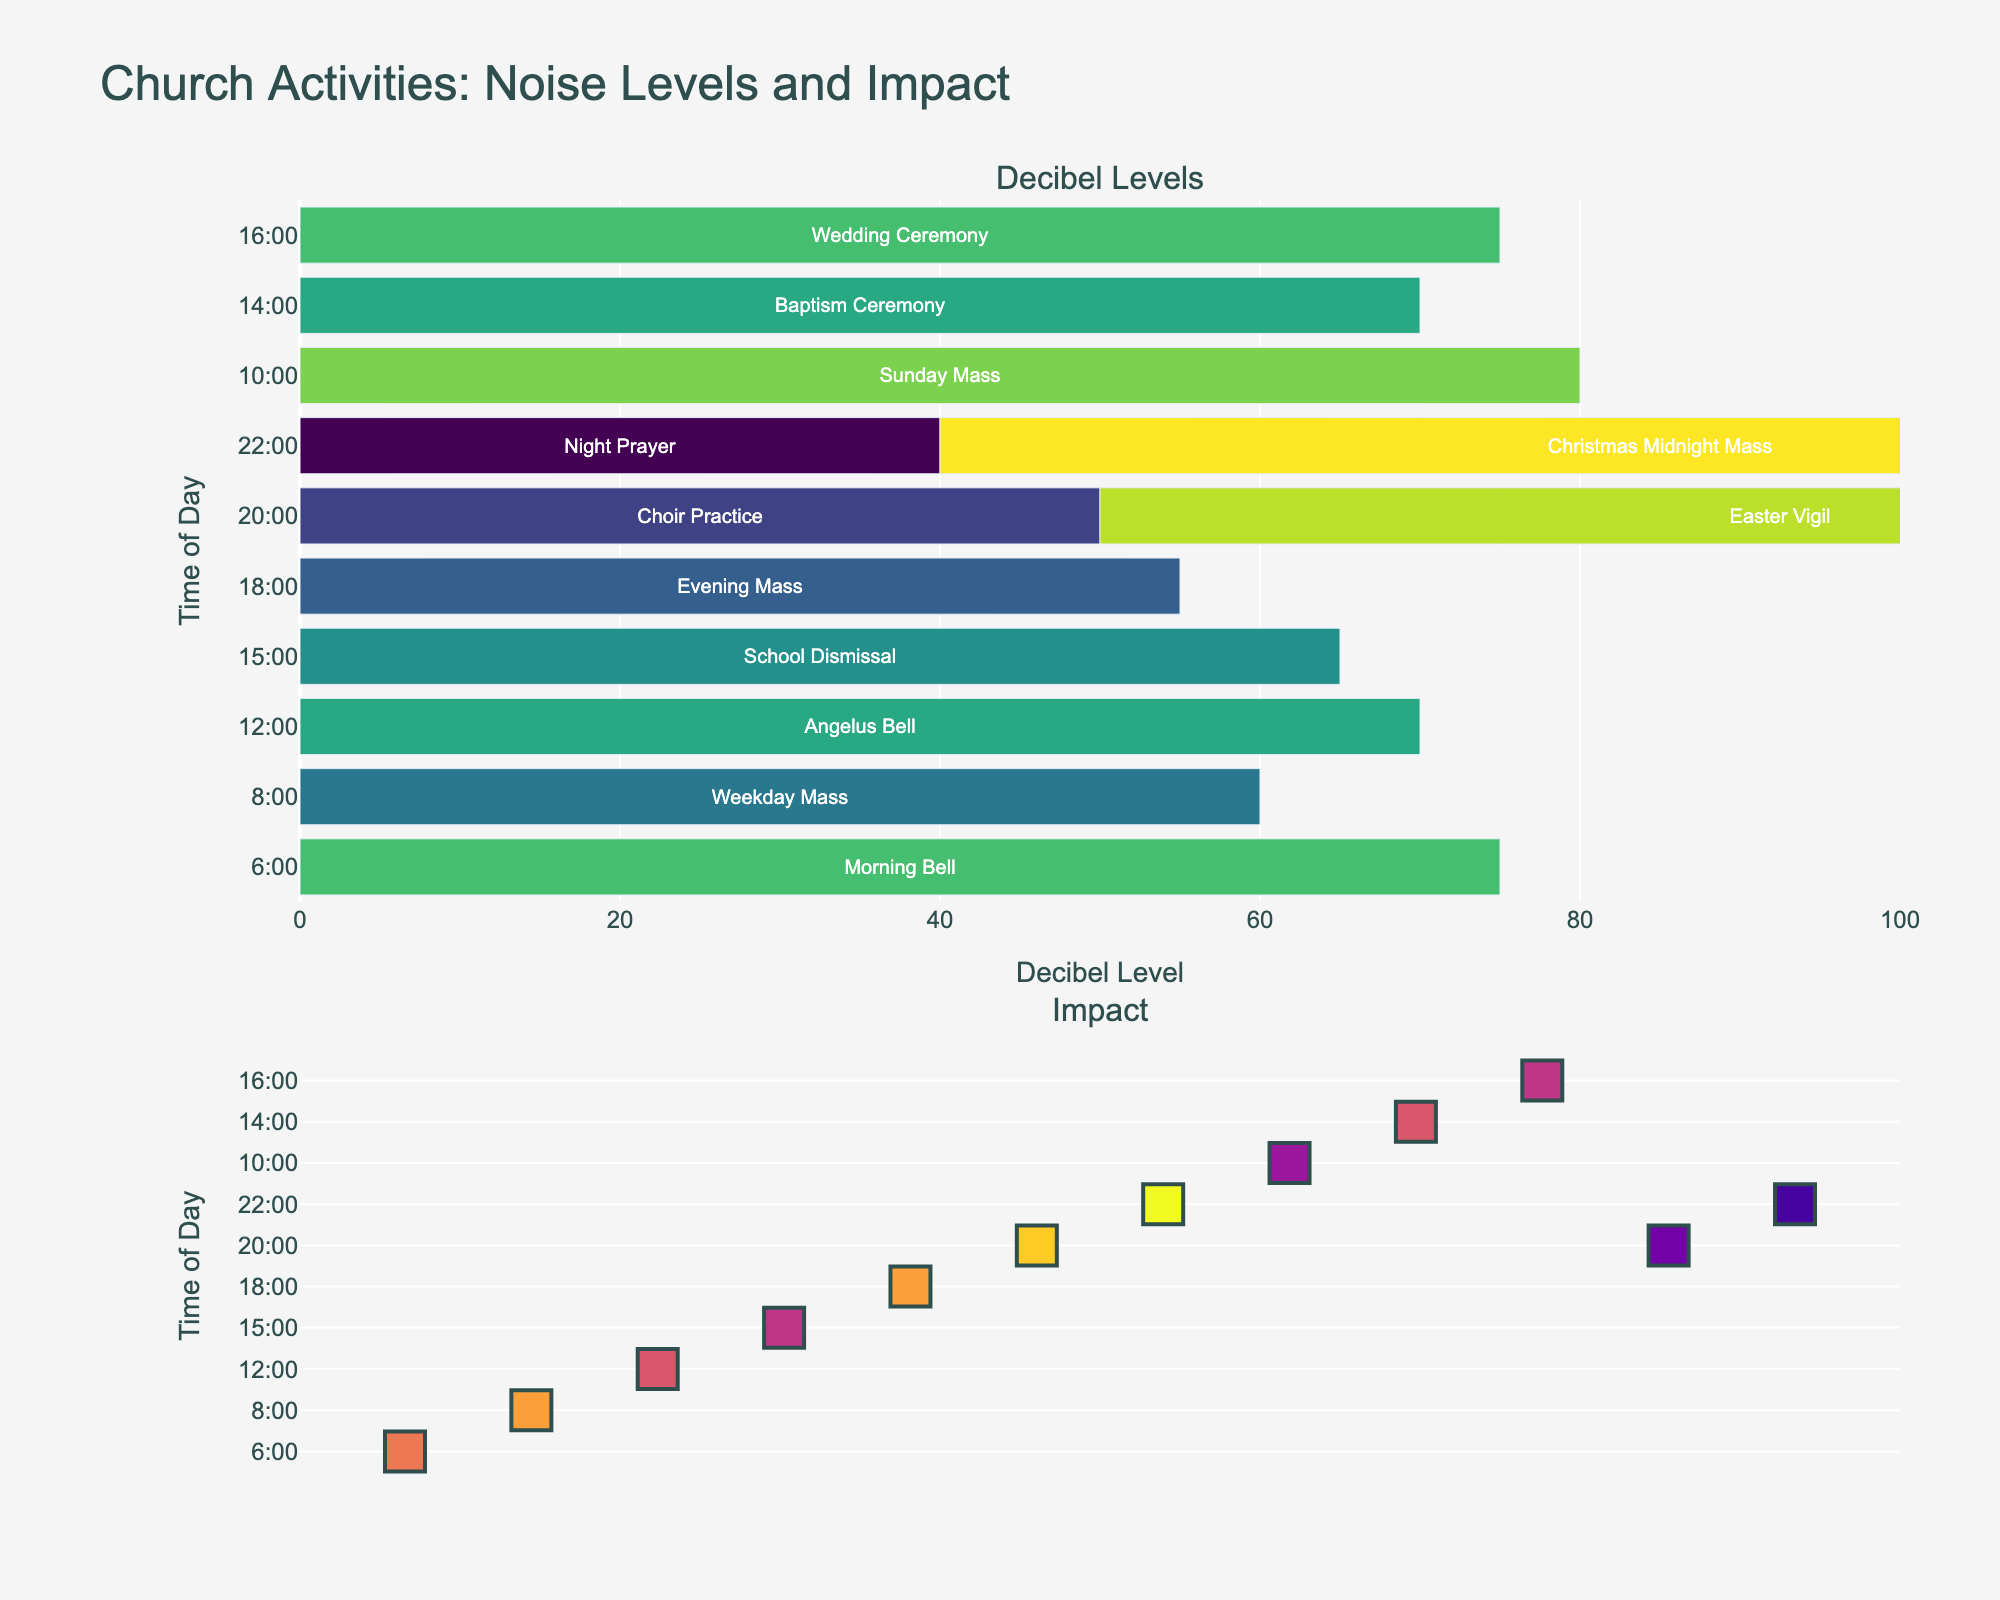What is the title of the figure? The title of the figure is displayed prominently at the top of the image and reads, "Comparison of Average Running Speeds for Different Long-Distance Events in Kenya."
Answer: Comparison of Average Running Speeds for Different Long-Distance Events in Kenya Which athlete has the highest average speed for the 5000m event? The subplot for the 5000m event shows that Rhonex Kipruto has the tallest bar, indicating the highest average speed among the athletes.
Answer: Rhonex Kipruto What is the speed difference between Eliud Kipchoge and Brigid Kosgei in the Marathon event? In the Marathon event subplot, the bar for Eliud Kipchoge shows a speed of 12.6 km/h, whereas Brigid Kosgei's speed is 12.2 km/h. The difference is 12.6 - 12.2 = 0.4 km/h.
Answer: 0.4 km/h Who has a consistent speed decrease pattern from 5000m to Marathon? By observing all four subplots, we can see that Eliud Kipchoge and Paul Tergat both follow a consistent speed decline from each event to the next (5000m, 10000m, Half Marathon, and Marathon).
Answer: Eliud Kipchoge, Paul Tergat Which event shows the least variation in average speeds among the athletes? The subplot for the 10000m event shows that the differences between the lengths of bars are smaller compared to other events, indicating less variation in speeds among the athletes.
Answer: 10000m How many athletes have an average speed greater than 13 km/h in the 5000m event? By examining the 5000m subplot, athletes who have bars extending above the 13 km/h mark are Eliud Kipchoge, Geoffrey Kamworor, Rhonex Kipruto, and Bernard Lagat, totaling to four athletes.
Answer: Four Amongst all events, who has the lowest average speed in the Half Marathon event? The Half Marathon subplot shows the shortest bar belongs to Vivian Cheruiyot, indicating she has the lowest average speed in this event.
Answer: Vivian Cheruiyot Which athlete shows the least variation in their average speeds across all events? Observing all the subplots, Faith Kipyegon shows minimal variation in the lengths of the bars across all events, indicating the least variation in average speeds.
Answer: Faith Kipyegon How does Hellen Obiri's speed in the Marathon compare to other athletes? In the Marathon event subplot, Hellen Obiri's speed is represented with a bar approximately at 12.3 km/h. Only Vivian Cheruiyot has a speed lower than 12.3 km/h, indicating Hellen Obiri's speed is second lowest.
Answer: Second lowest 